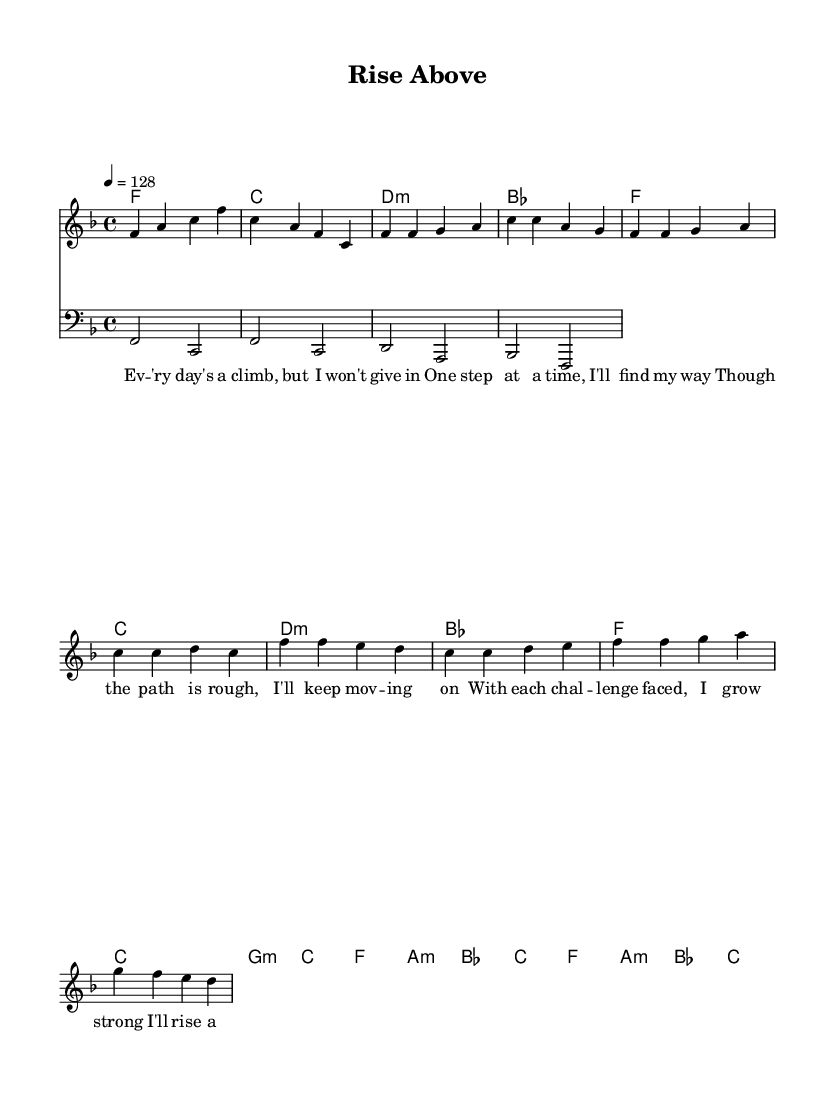What is the key signature of this music? The key signature is F major, which contains one flat (B flat). This can be identified at the beginning of the staff.
Answer: F major What is the time signature of this music? The time signature is 4/4, indicated at the beginning of the music with a "4" over a "4". This means there are four beats in each measure.
Answer: 4/4 What is the tempo marking of this music? The tempo marking is 128 beats per minute, denoted by the "4 = 128" at the beginning, showing how quickly the piece should be played.
Answer: 128 How many measures are in the verse section? The verse has 8 measures, which can be counted by examining the lines of music and grouping them by their respective bars.
Answer: 8 What are the main themes of the lyrics in this song? The main themes of the lyrics focus on overcoming challenges and perseverance, as stated in phrases like "I won't give in" and "I'll rise above". The lyrics emphasize resilience.
Answer: Overcoming obstacles What is the structure of the song, including the sections? The structure comprises an intro, a verse, and a chorus. This can be seen through the layout of the music where distinct sections are marked and recognizable by changes in melody and harmony.
Answer: Intro, Verse, Chorus What type of music is this based on its characteristics? This music is categorized as uplifting house music, evident from its rhythmic instrumentation and positive lyrical themes aimed at energizing listeners.
Answer: Uplifting house music 